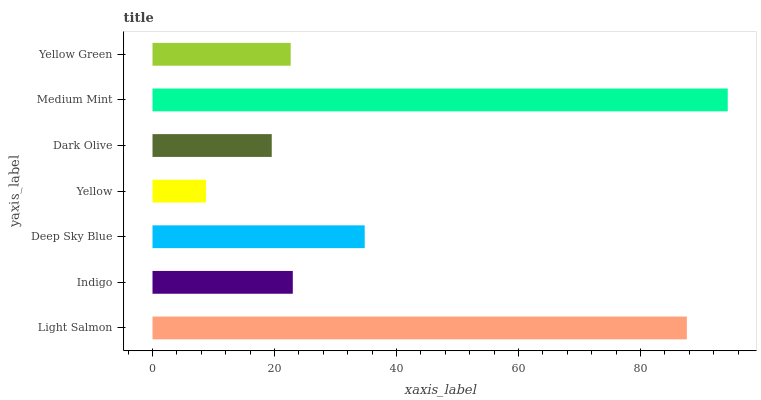Is Yellow the minimum?
Answer yes or no. Yes. Is Medium Mint the maximum?
Answer yes or no. Yes. Is Indigo the minimum?
Answer yes or no. No. Is Indigo the maximum?
Answer yes or no. No. Is Light Salmon greater than Indigo?
Answer yes or no. Yes. Is Indigo less than Light Salmon?
Answer yes or no. Yes. Is Indigo greater than Light Salmon?
Answer yes or no. No. Is Light Salmon less than Indigo?
Answer yes or no. No. Is Indigo the high median?
Answer yes or no. Yes. Is Indigo the low median?
Answer yes or no. Yes. Is Deep Sky Blue the high median?
Answer yes or no. No. Is Medium Mint the low median?
Answer yes or no. No. 